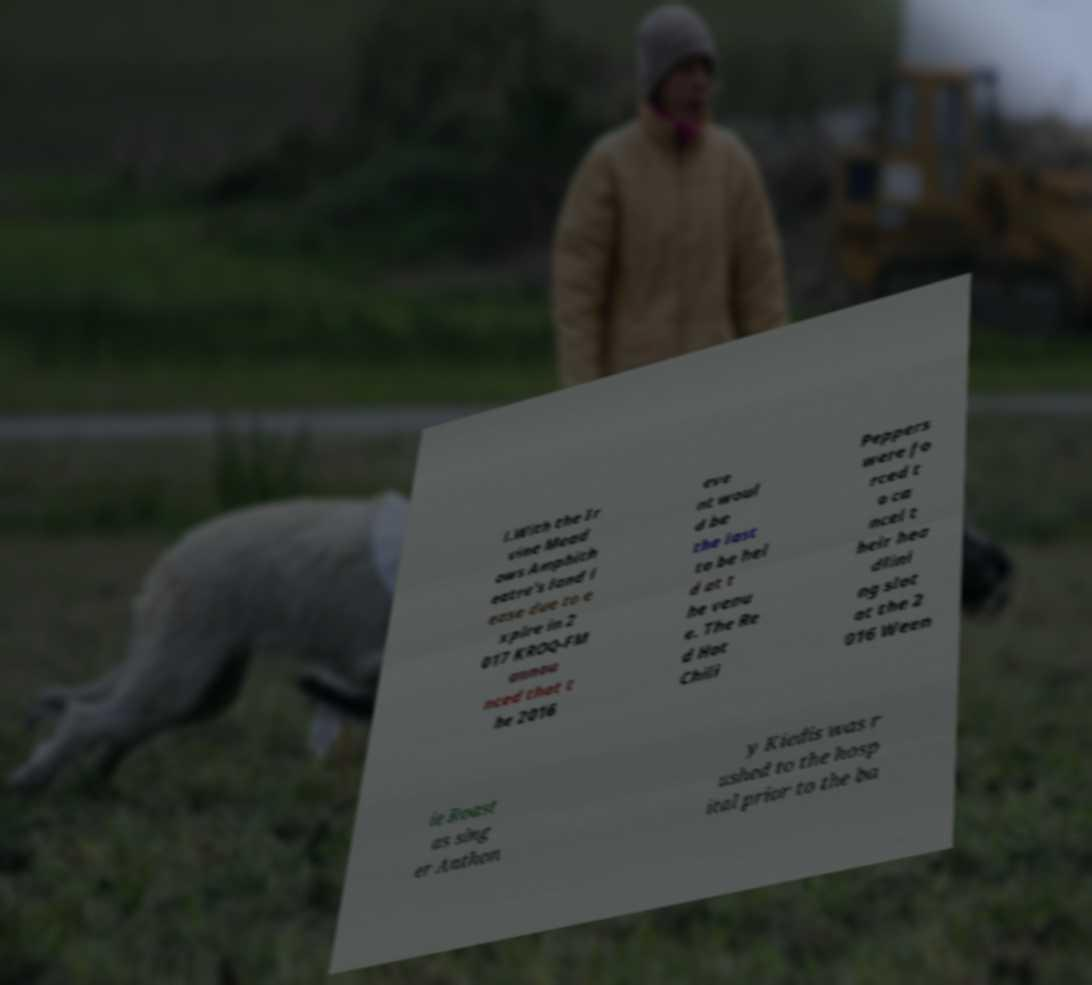Please identify and transcribe the text found in this image. l.With the Ir vine Mead ows Amphith eatre's land l ease due to e xpire in 2 017 KROQ-FM annou nced that t he 2016 eve nt woul d be the last to be hel d at t he venu e. The Re d Hot Chili Peppers were fo rced t o ca ncel t heir hea dlini ng slot at the 2 016 Ween ie Roast as sing er Anthon y Kiedis was r ushed to the hosp ital prior to the ba 